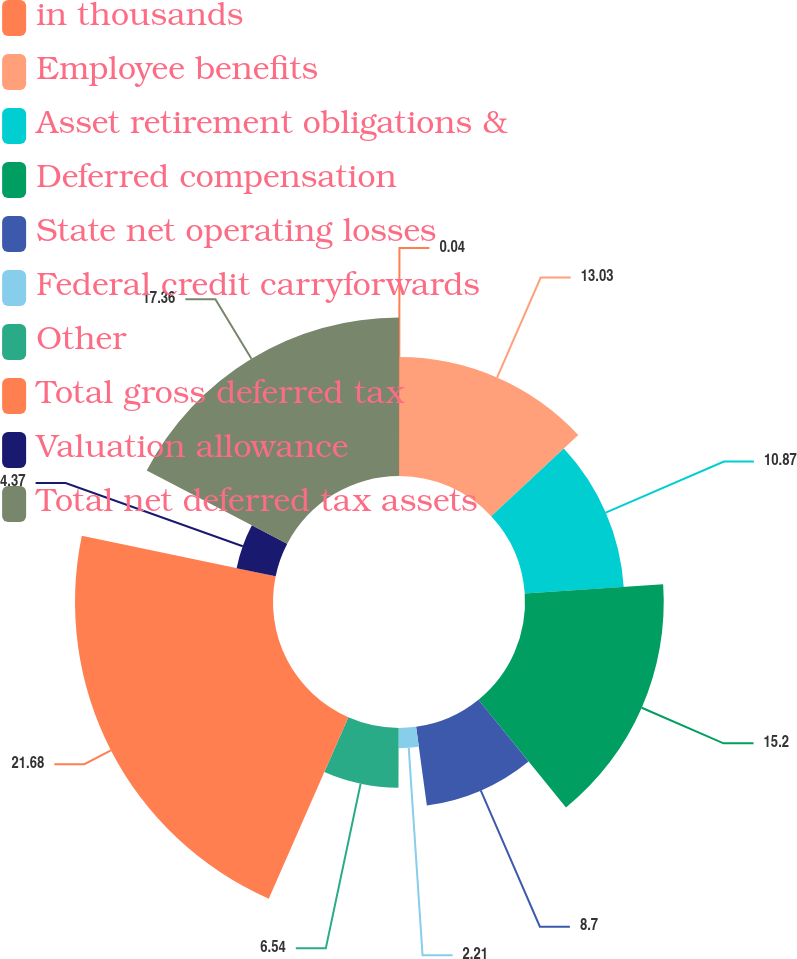Convert chart to OTSL. <chart><loc_0><loc_0><loc_500><loc_500><pie_chart><fcel>in thousands<fcel>Employee benefits<fcel>Asset retirement obligations &<fcel>Deferred compensation<fcel>State net operating losses<fcel>Federal credit carryforwards<fcel>Other<fcel>Total gross deferred tax<fcel>Valuation allowance<fcel>Total net deferred tax assets<nl><fcel>0.04%<fcel>13.03%<fcel>10.87%<fcel>15.2%<fcel>8.7%<fcel>2.21%<fcel>6.54%<fcel>21.69%<fcel>4.37%<fcel>17.36%<nl></chart> 